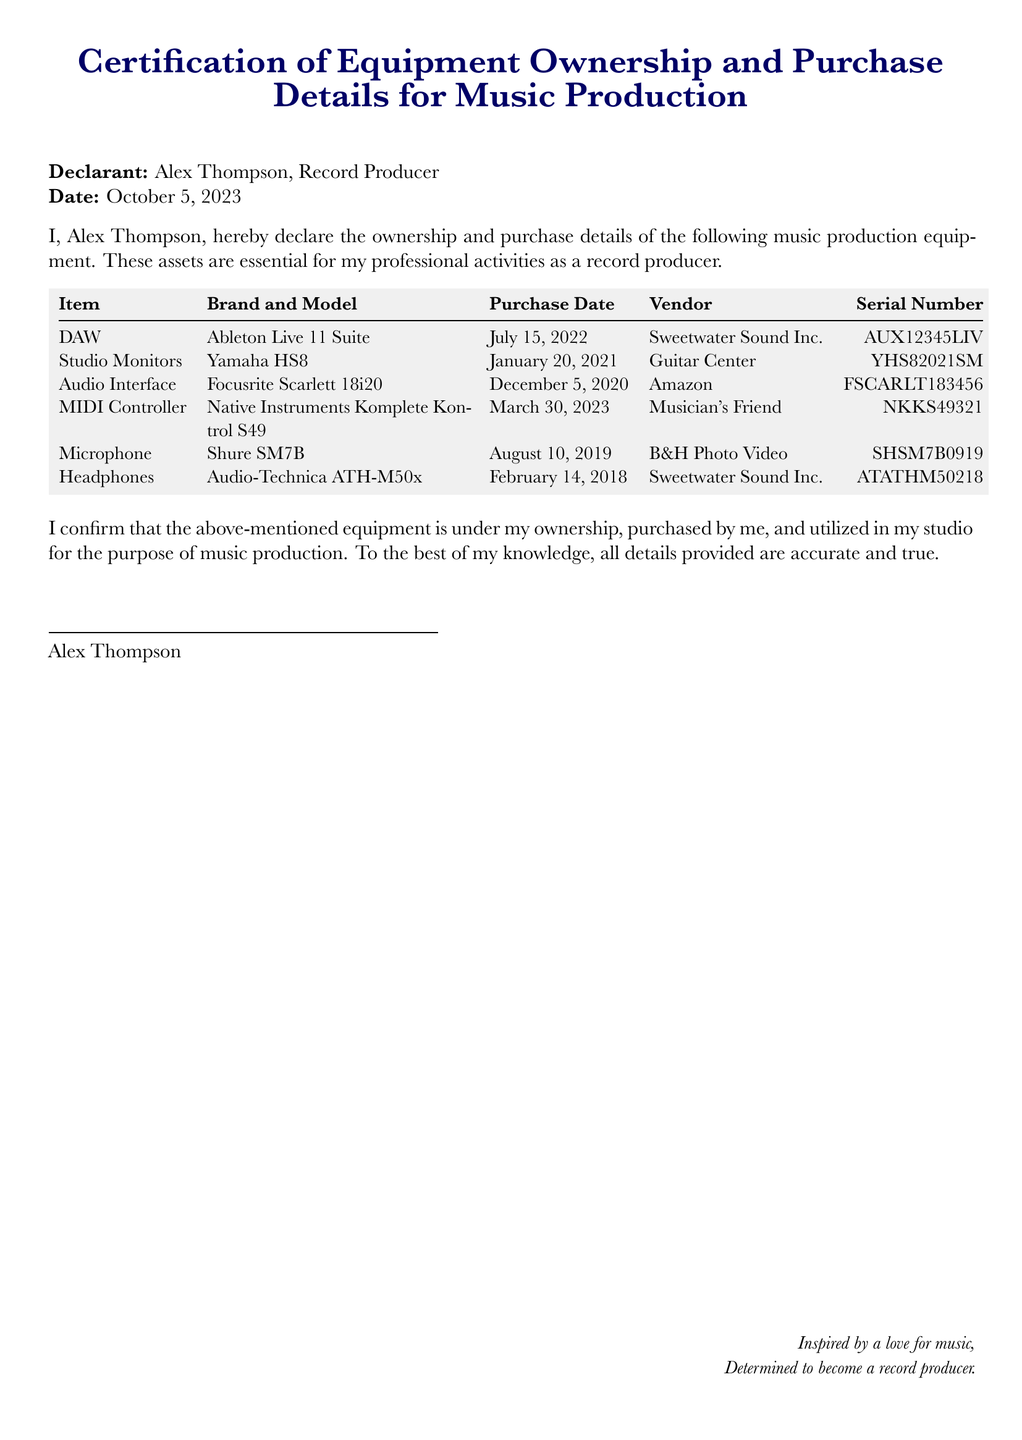What is the name of the declarant? The declarant's name is provided at the beginning of the document.
Answer: Alex Thompson What is the purchase date of the MIDI Controller? The purchase date for the MIDI Controller is indicated in the table in the document.
Answer: March 30, 2023 What equipment is listed under the brand Native Instruments? This question asks for the specific item related to the given brand from the table.
Answer: Komplete Kontrol S49 How many items are listed in the document? The total number of items is derived from counting the entries in the equipment table.
Answer: 6 What is the vendor for the Audio Interface? The vendor information for the Audio Interface can be found in the corresponding row of the table.
Answer: Amazon What is the serial number of the Studio Monitors? The serial number is mentioned along with the other details in the table for the Studio Monitors.
Answer: YHS82021SM What is the purpose of the equipment mentioned in the declaration? The purpose is stated clearly in the declaration section of the document.
Answer: Music production What is the date of the declaration? The date can be found where the declarant's details are listed in the document.
Answer: October 5, 2023 What is the brand of the Microphone listed? The brand of the Microphone is given directly in the equipment table.
Answer: Shure 